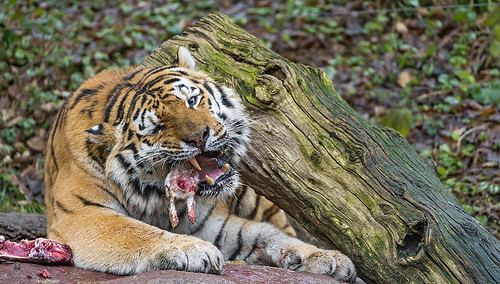<image>
Is the tiger on the branch? No. The tiger is not positioned on the branch. They may be near each other, but the tiger is not supported by or resting on top of the branch. 